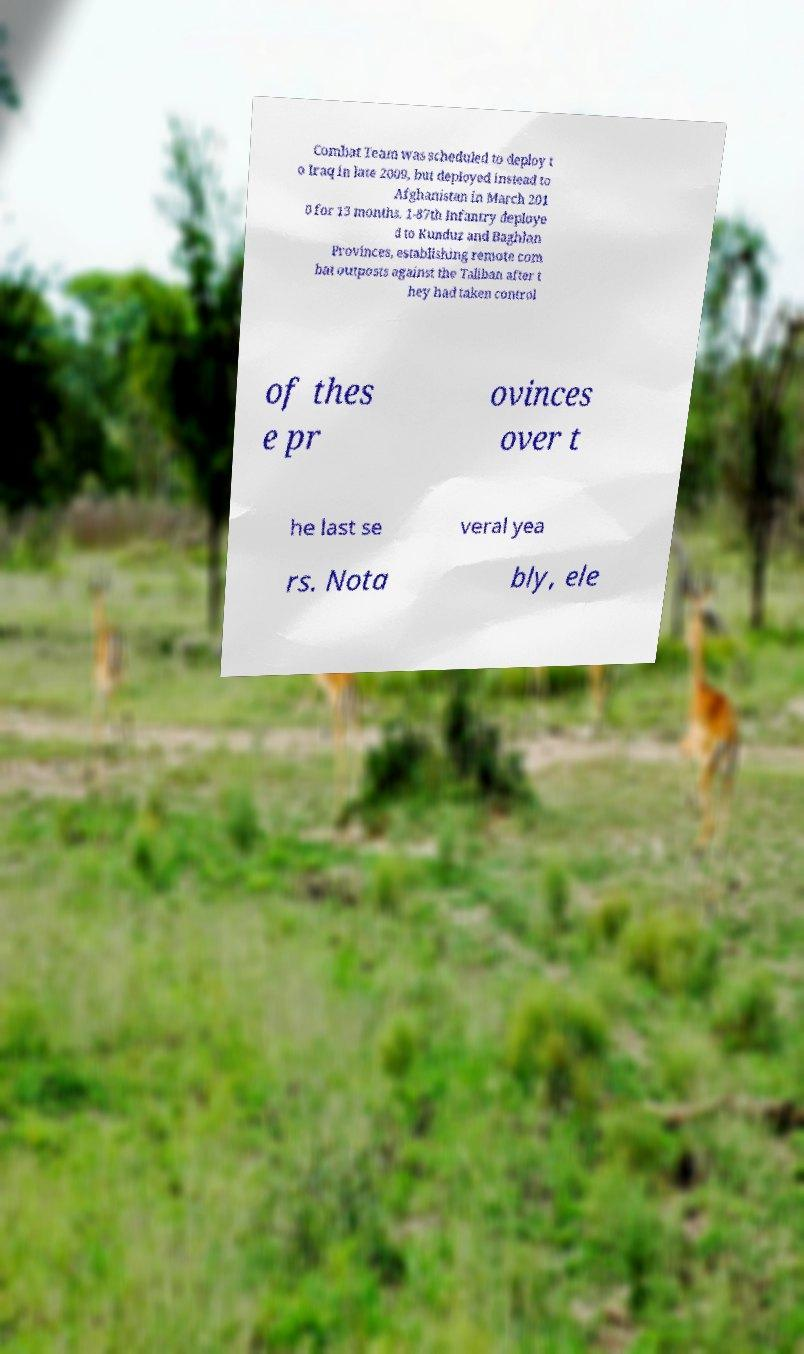Can you accurately transcribe the text from the provided image for me? Combat Team was scheduled to deploy t o Iraq in late 2009, but deployed instead to Afghanistan in March 201 0 for 13 months. 1-87th Infantry deploye d to Kunduz and Baghlan Provinces, establishing remote com bat outposts against the Taliban after t hey had taken control of thes e pr ovinces over t he last se veral yea rs. Nota bly, ele 